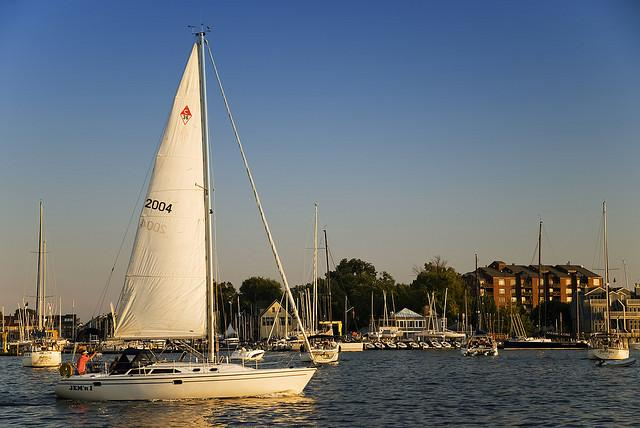What material is the sail mast made of?

Choices:
A) wood
B) aluminum
C) copper
D) iron aluminum 